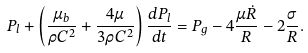Convert formula to latex. <formula><loc_0><loc_0><loc_500><loc_500>P _ { l } + \left ( \frac { \mu _ { b } } { \rho C ^ { 2 } } + \frac { 4 \mu } { 3 \rho C ^ { 2 } } \right ) \frac { d P _ { l } } { d t } = P _ { g } - 4 \frac { \mu \dot { R } } { R } - 2 \frac { \sigma } { R } .</formula> 